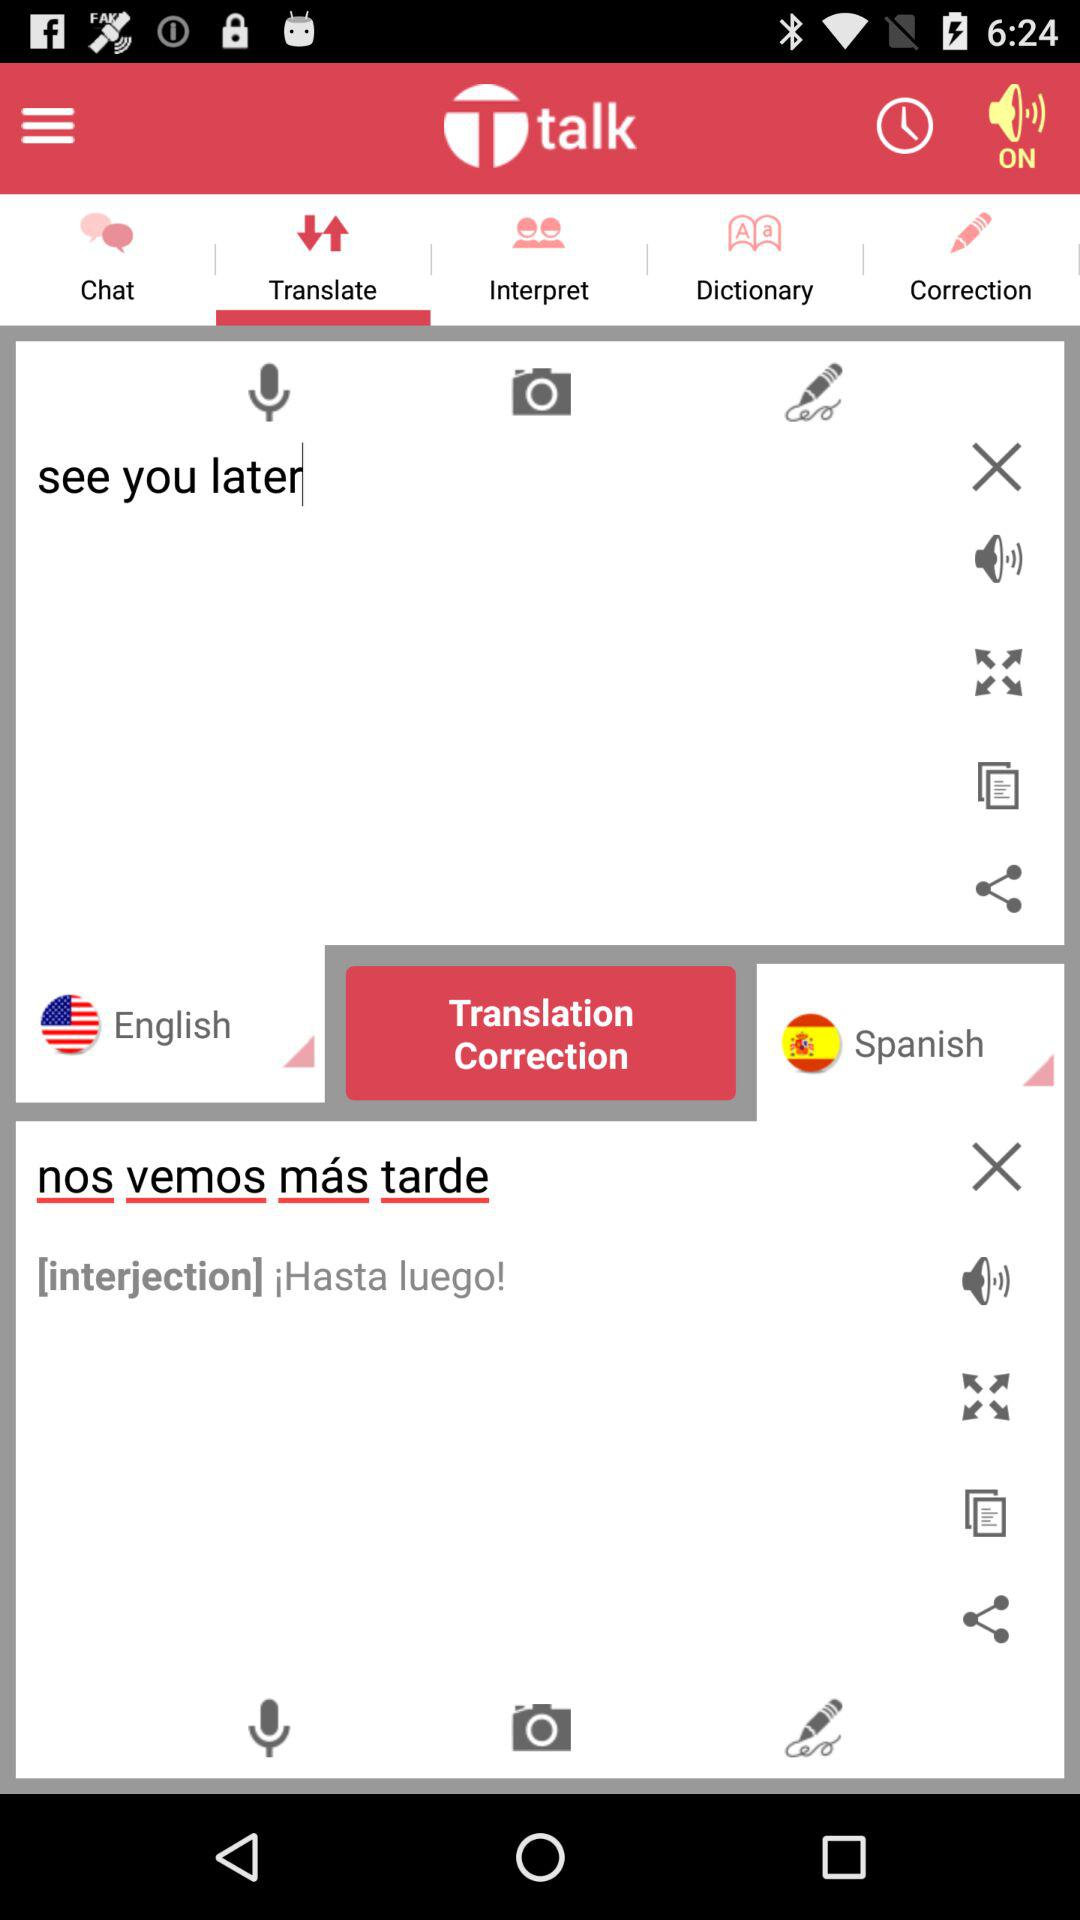What is the application name? The application name is "Ttalk". 